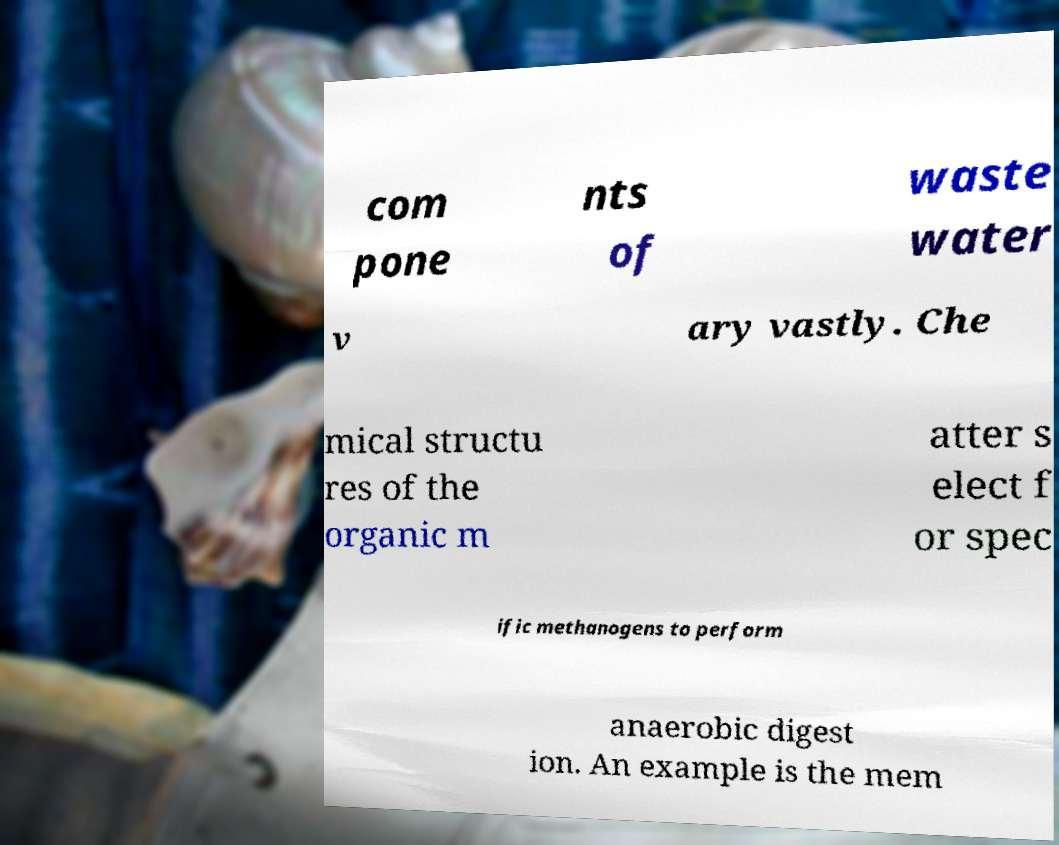Can you read and provide the text displayed in the image?This photo seems to have some interesting text. Can you extract and type it out for me? com pone nts of waste water v ary vastly. Che mical structu res of the organic m atter s elect f or spec ific methanogens to perform anaerobic digest ion. An example is the mem 